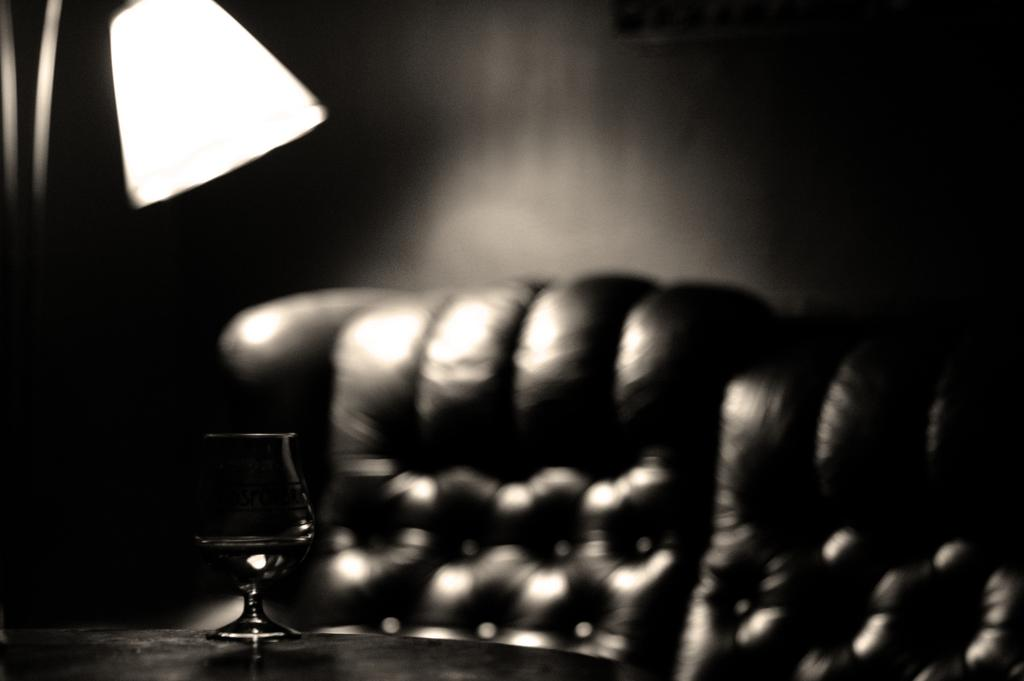What object is located on the left side of the image? There is a lamp on the left side of the image. What can be seen in the front of the image? There is a glass in the front of the image. What type of furniture is at the back of the image? There is a couch at the back of the image. How is the image presented in terms of color? The image is black and white. What is the manager's role in the image? There is no manager present in the image. What is the distance between the lamp and the couch in the image? The facts provided do not give information about the distance between the lamp and the couch. 